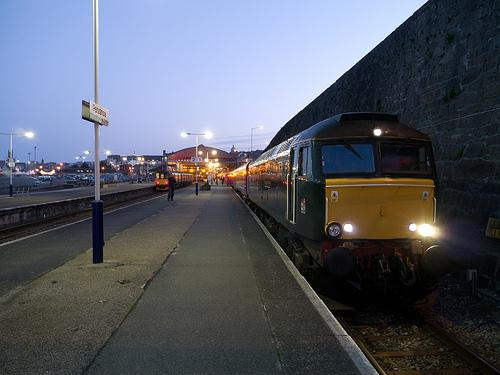Describe the scene of the train and its surroundings. A train is on the tracks with lights at its front, pulling passenger cars near a stone wall, with a train station and platform next to it, and the city in the background under a blue sky. What are people doing at the train station? People are waiting to board the train, with a man standing alone near the tracks and another person in black also waiting for the train on the platform. List the lighting elements found in the image. The lights on the train, a brightly lit street light, and multiple white street lights are all visible in the image. Mention the color of the train and any additional information about it. The train is yellow, green, black, and red, with a yellow front and blue and white sign post, and has two large windows and working lights on the front. Discuss the types of materials used in the construction of the train station and its surroundings. The train station is built with a red roof, the tracks are made of steel, and the divider between the tracks is made out of cement, also there is a tall brick wall beside the tracks. What are the different colors found in the sign? The sign is white and blue with red letters on it. Analyze the image and identify any possible anomalies. One light on the front of the train is not on, while the others are lit, which might indicate a malfunction or broken bulb. Based on the image, share the sentiment or mood displayed. The overall mood is busy and bustling, as people are waiting to board the train, a man stands alone near the tracks thinking, street lights are illuminated, and cars fill the parking lot, showing an active train station scene. What are the visible characteristics of the main structure next to the train tracks? The main structure next to the tracks is the train station, featuring a red roof, a platform with light poles and a white and blue sign, a parking lot nearby, and an area of dead grass between two sidewalks. Provide a brief description of the station and its surroundings. The train station has a red roof and is next to cement tracks with gravel, a grey concrete platform with light poles, a parking lot full of cars, and an area of dead grass between sidewalks. 